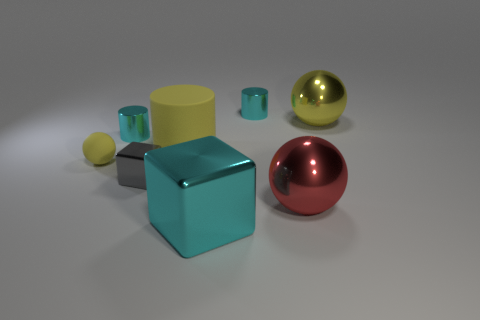There is a large sphere that is in front of the yellow shiny ball; is its color the same as the big rubber object?
Give a very brief answer. No. What number of objects are either yellow things behind the large matte thing or big green rubber balls?
Your response must be concise. 1. Are there more cyan cylinders to the left of the tiny yellow ball than matte balls that are in front of the gray metal cube?
Your response must be concise. No. Do the big cyan cube and the large red object have the same material?
Your answer should be very brief. Yes. The large object that is behind the big cyan metal cube and in front of the yellow matte cylinder has what shape?
Offer a terse response. Sphere. What shape is the big yellow thing that is the same material as the tiny yellow sphere?
Offer a terse response. Cylinder. Are there any big brown matte spheres?
Provide a succinct answer. No. Is there a object that is behind the tiny cyan cylinder that is right of the cyan cube?
Ensure brevity in your answer.  No. There is another tiny thing that is the same shape as the yellow metal object; what material is it?
Your answer should be compact. Rubber. Are there more yellow metallic cylinders than red things?
Your answer should be very brief. No. 